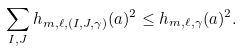<formula> <loc_0><loc_0><loc_500><loc_500>\sum _ { I , J } h _ { m , \ell , ( I , J , \gamma ) } ( a ) ^ { 2 } \leq h _ { m , \ell , \gamma } ( a ) ^ { 2 } .</formula> 